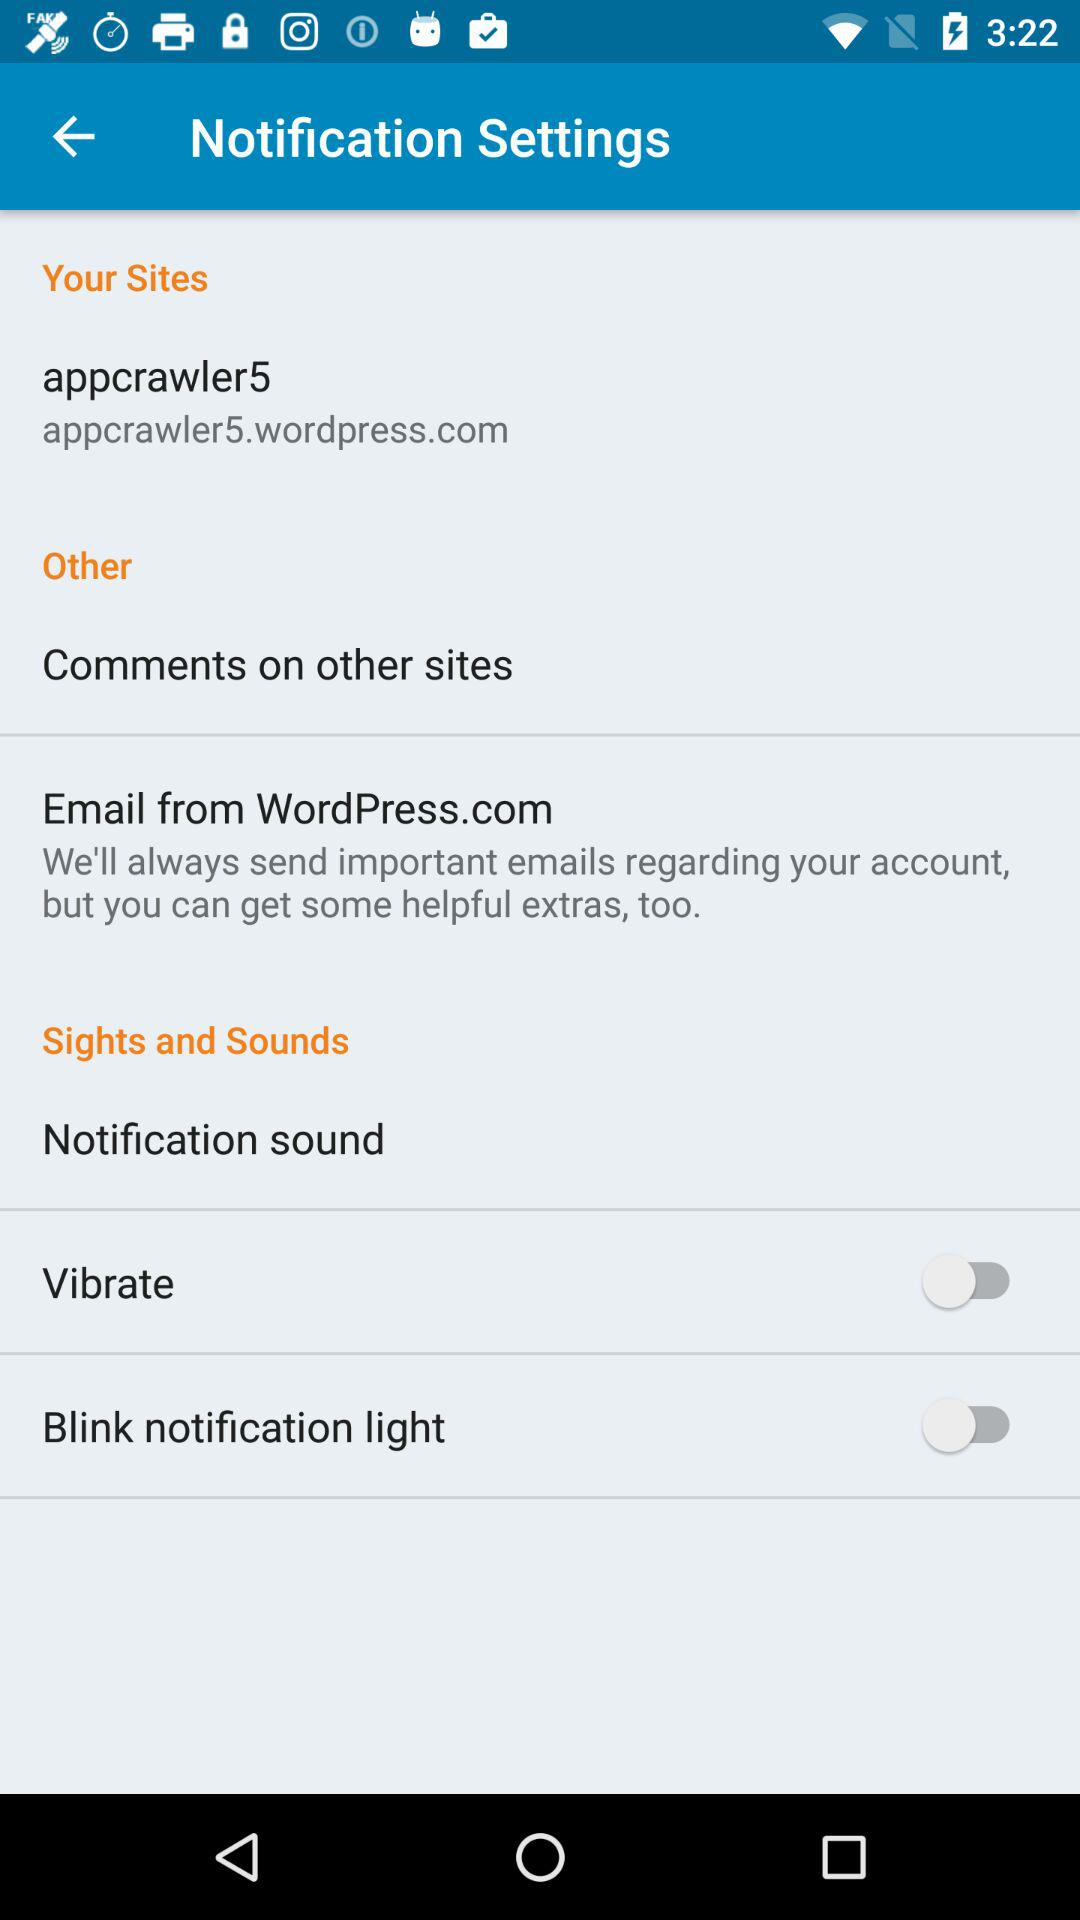What is the status of the "Blink notification light"? The status is "off". 